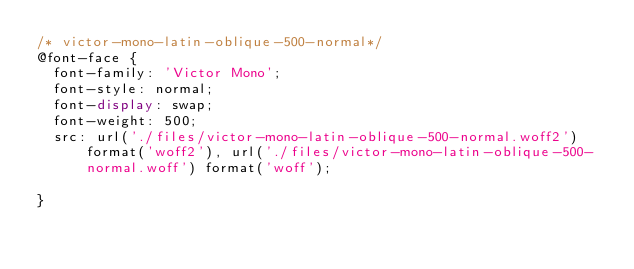Convert code to text. <code><loc_0><loc_0><loc_500><loc_500><_CSS_>/* victor-mono-latin-oblique-500-normal*/
@font-face {
  font-family: 'Victor Mono';
  font-style: normal;
  font-display: swap;
  font-weight: 500;
  src: url('./files/victor-mono-latin-oblique-500-normal.woff2') format('woff2'), url('./files/victor-mono-latin-oblique-500-normal.woff') format('woff');
  
}
</code> 